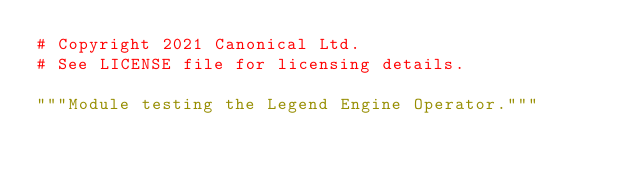<code> <loc_0><loc_0><loc_500><loc_500><_Python_># Copyright 2021 Canonical Ltd.
# See LICENSE file for licensing details.

"""Module testing the Legend Engine Operator."""
</code> 